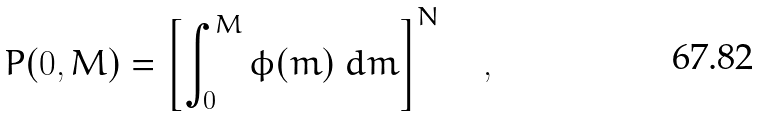<formula> <loc_0><loc_0><loc_500><loc_500>P ( 0 , M ) = \left [ \int _ { 0 } ^ { M } \phi ( m ) \ d m \right ] ^ { N } \quad ,</formula> 